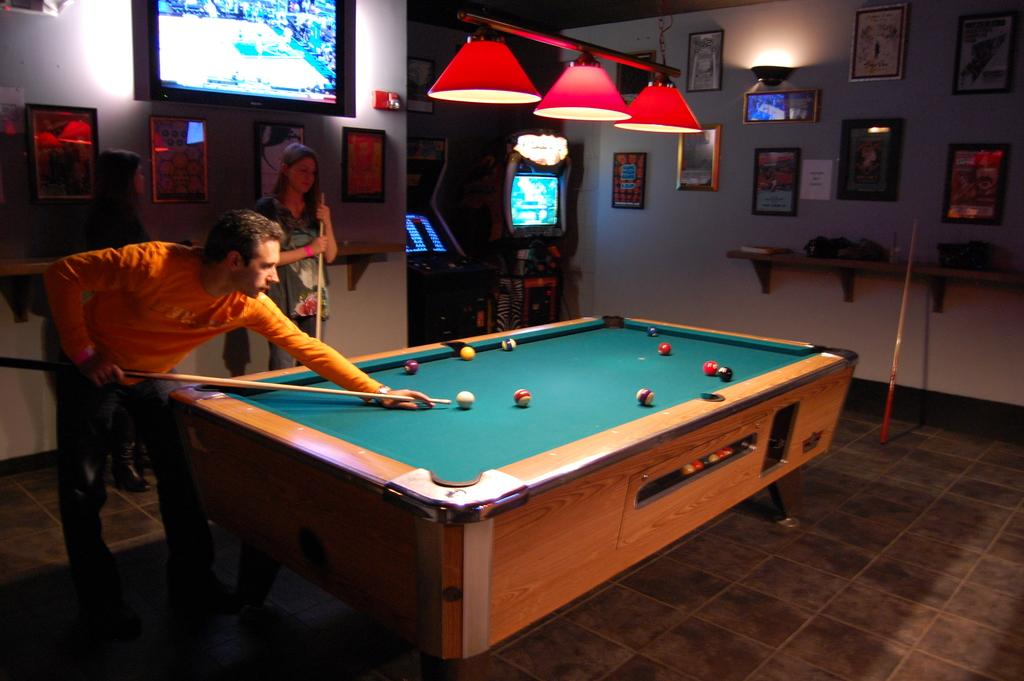What activity are the two people engaged in within the image? Two people are playing snooker in the image. What can be seen on the wall in the background? There are posts attached to the wall in the background. Can you describe the lady in the image? There is a lady in the image, and she is viewing the television. What type of footwear is the lady wearing while washing dishes at the sink in the image? There is no sink or lady wearing footwear in the image. The lady is viewing the television, and there is no mention of her washing dishes. 